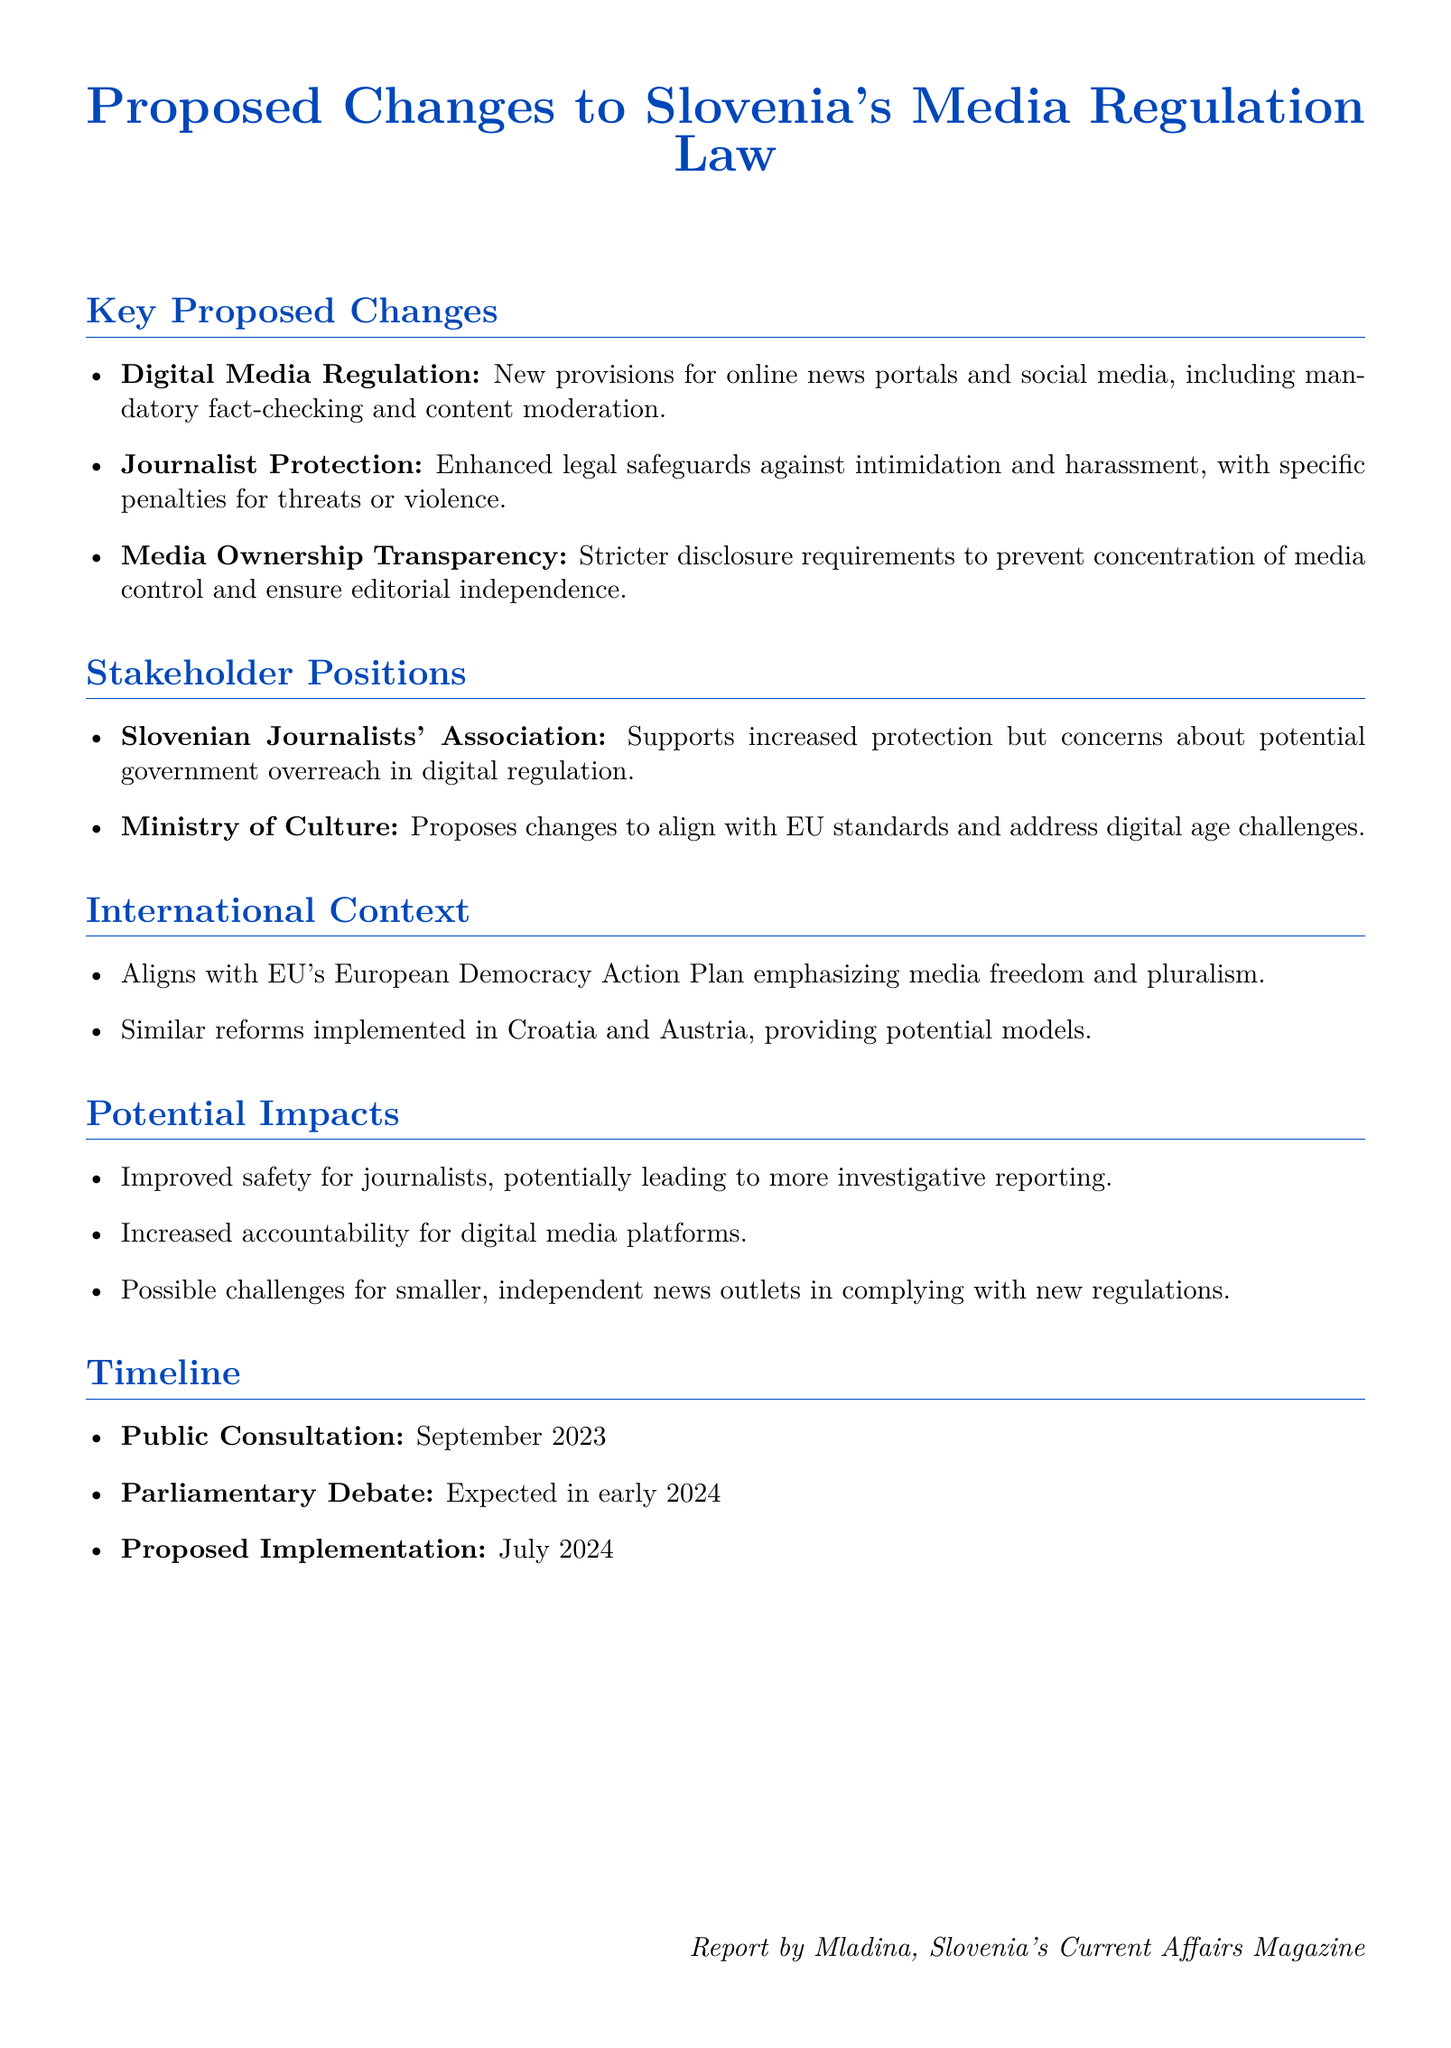What are the new provisions for online news portals? The document mentions mandatory fact-checking and content moderation as new provisions for online news portals.
Answer: mandatory fact-checking and content moderation What is the main concern of the Slovenian Journalists' Association? The document indicates that the Slovenian Journalists' Association supports increased protection but has concerns about potential government overreach in digital regulation.
Answer: potential government overreach When is the public consultation for the proposed changes scheduled? According to the document, the public consultation is scheduled for September 2023.
Answer: September 2023 What are the specific penalties mentioned related to journalist protection? The document states that there will be enhanced legal safeguards against intimidation and harassment, with specific penalties for threats or violence.
Answer: specific penalties for threats or violence What is the expected date for the parliamentary debate on the proposed changes? The document notes that the parliamentary debate is expected in early 2024.
Answer: early 2024 Which international plan does the proposed changes align with? The document mentions alignment with the EU's European Democracy Action Plan.
Answer: European Democracy Action Plan What potential challenges are noted for smaller news outlets? The document highlights possible challenges for smaller, independent news outlets in complying with new regulations.
Answer: complying with new regulations What is one potential impact of improved safety for journalists? The document suggests that improved safety for journalists could lead to more investigative reporting.
Answer: more investigative reporting 